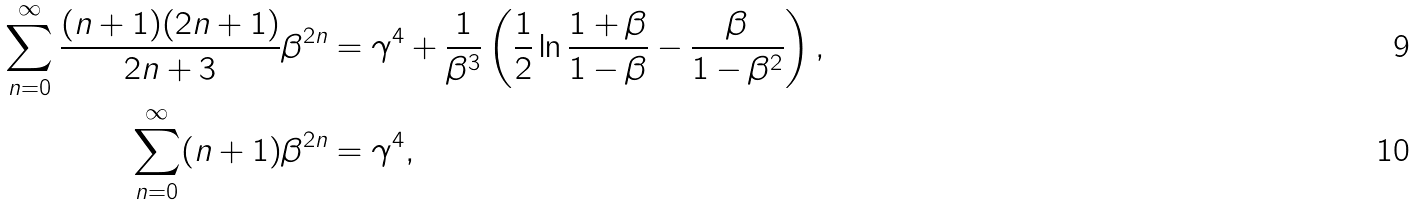<formula> <loc_0><loc_0><loc_500><loc_500>\sum _ { n = 0 } ^ { \infty } \frac { ( n + 1 ) ( 2 n + 1 ) } { 2 n + 3 } \beta ^ { 2 n } & = \gamma ^ { 4 } + \frac { 1 } { \beta ^ { 3 } } \left ( \frac { 1 } { 2 } \ln \frac { 1 + \beta } { 1 - \beta } - \frac { \beta } { 1 - \beta ^ { 2 } } \right ) , \\ \sum _ { n = 0 } ^ { \infty } ( n + 1 ) \beta ^ { 2 n } & = \gamma ^ { 4 } ,</formula> 